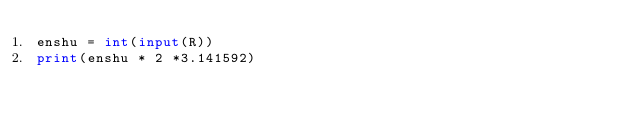Convert code to text. <code><loc_0><loc_0><loc_500><loc_500><_Python_>enshu = int(input(R))
print(enshu * 2 *3.141592)

</code> 